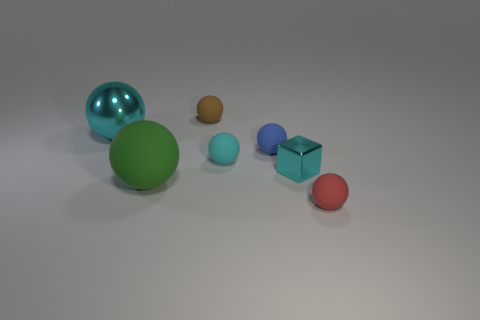The rubber thing that is the same color as the tiny metallic block is what shape?
Offer a very short reply. Sphere. What size is the matte object that is the same color as the metal block?
Provide a short and direct response. Small. Is the color of the big metallic object the same as the shiny block?
Offer a very short reply. Yes. Is there a small cyan cube that has the same material as the red object?
Provide a short and direct response. No. What is the shape of the tiny metal thing?
Your answer should be compact. Cube. Is the cube the same size as the blue sphere?
Your answer should be very brief. Yes. How many other objects are the same shape as the red thing?
Offer a terse response. 5. What shape is the shiny thing on the left side of the green sphere?
Your answer should be compact. Sphere. There is a shiny object that is behind the tiny blue object; is it the same shape as the cyan metal thing to the right of the big green rubber sphere?
Keep it short and to the point. No. Are there an equal number of small red balls to the left of the cyan rubber thing and green rubber things?
Keep it short and to the point. No. 